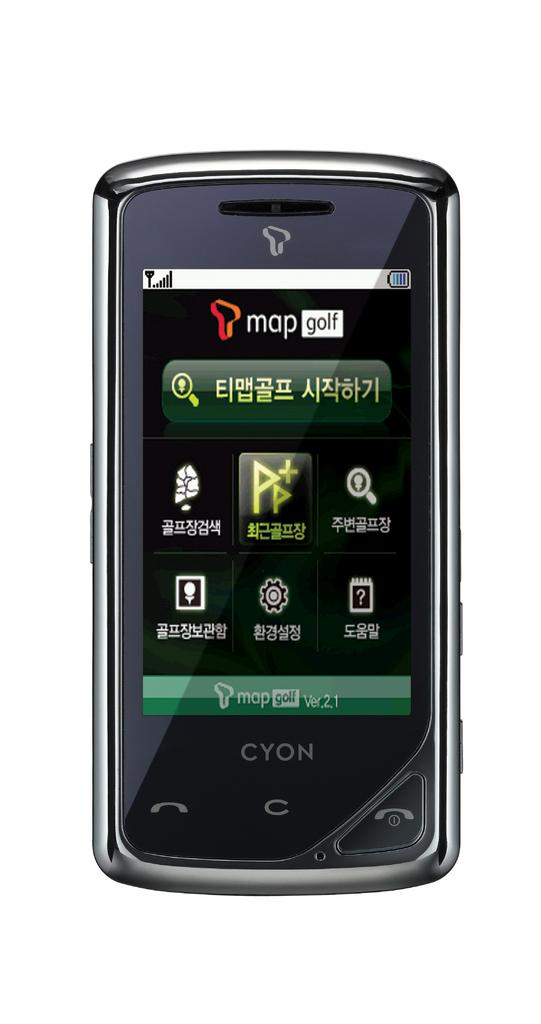Provide a one-sentence caption for the provided image. Cyon phone has many apps including 'map golf'. 